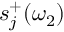<formula> <loc_0><loc_0><loc_500><loc_500>s _ { j } ^ { + } ( \omega _ { 2 } )</formula> 